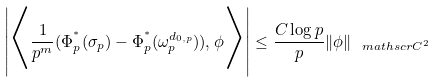Convert formula to latex. <formula><loc_0><loc_0><loc_500><loc_500>\left | \Big < \frac { 1 } { p ^ { m } } ( \Phi _ { p } ^ { ^ { * } } ( \sigma _ { p } ) - \Phi _ { p } ^ { ^ { * } } ( \omega _ { p } ^ { d _ { 0 , p } } ) ) , \phi \Big > \right | \leq \frac { C \log p } { p } \| \phi \| _ { \ m a t h s c r { C } ^ { 2 } }</formula> 